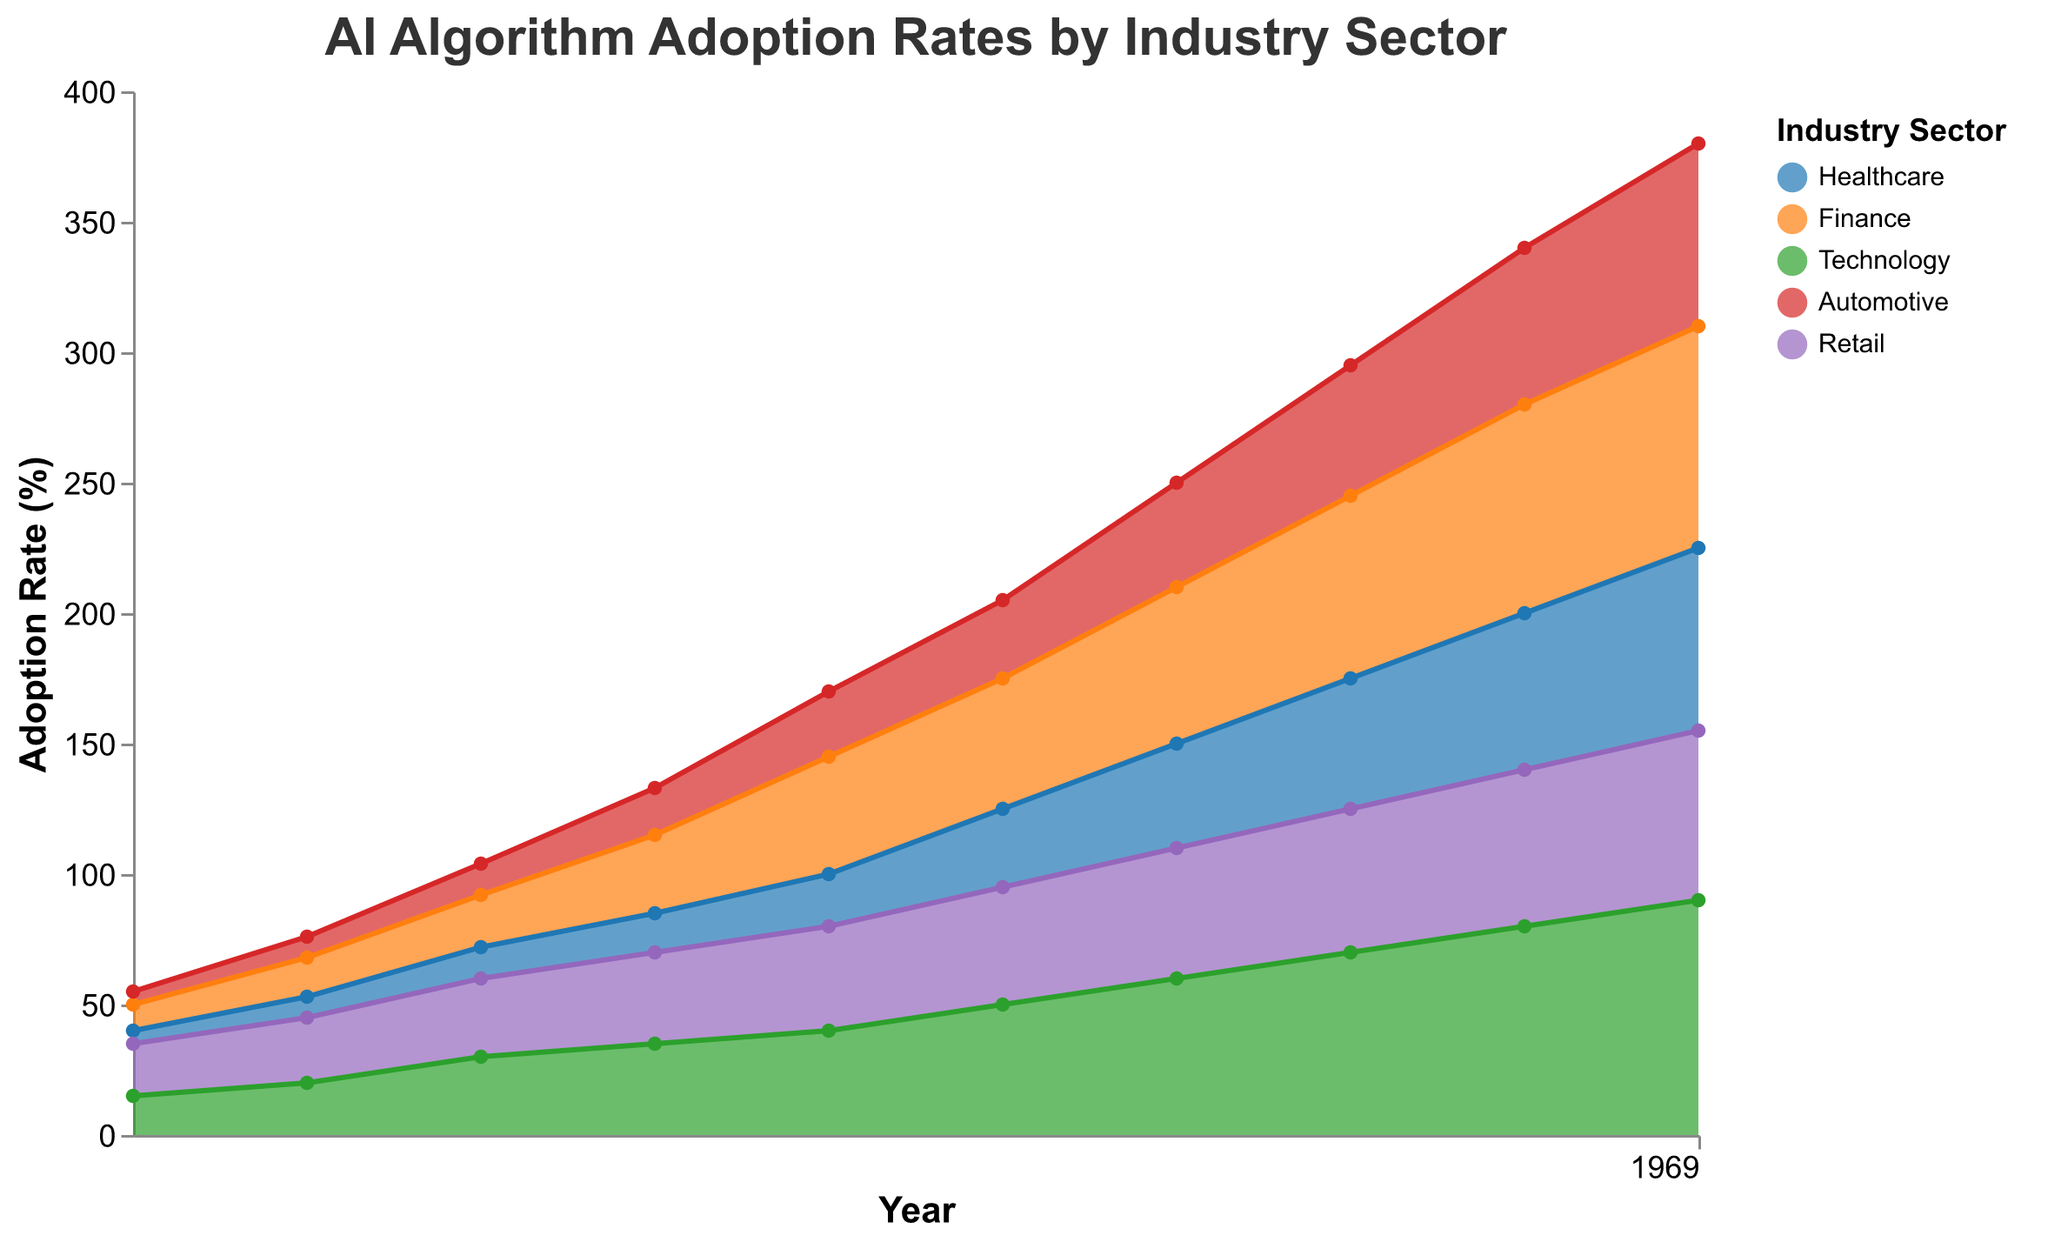What is the title of the figure? The title of the figure is visible at the top and reads "AI Algorithm Adoption Rates by Industry Sector".
Answer: AI Algorithm Adoption Rates by Industry Sector How many industry sectors are covered in the figure? Observe the color legend on the right side of the figure, which lists all industry sectors: "Healthcare", "Finance", "Technology", "Automotive", and "Retail".
Answer: 5 Which industry had the highest AI adoption rate in 2020? By looking at the 2020 vertical line, the highest point reached is in the "Technology" sector with an adoption rate of 70%.
Answer: Technology In which year did the AI adoption rate in the Healthcare sector first exceed 20%? Trace the Healthcare area until the adoption rate first surpasses the 20% mark, which happens in 2017.
Answer: 2017 How did the adoption rate in the Automotive sector change from 2013 to 2022? Check the beginning value for the Automotive sector in 2013 (5%) and the ending value in 2022 (70%). The adoption rate increased by 65%.
Answer: Increased by 65% What is the average AI adoption rate in the Finance sector over the decade? Sum the Finance adoption rates for each year (10, 15, 20, 30, 45, 50, 60, 70, 80, 85) and divide by the number of years (10). The average rate is 46.5%.
Answer: 46.5% Which industry showed the slowest growth in AI adoption between 2013 and 2022? Compare the total increase of adoption rates over the period for each industry. The Retail sector increased from 20% to 65%, a rise of 45%, which is the smallest among all sectors.
Answer: Retail How did the AI adoption trends in Retail and Technology compare over the last decade? Compare the trend lines for Retail and Technology. Retail increased from 20% to 65%, while Technology increased from 15% to 90%. Technology shows a steeper and larger increase.
Answer: Technology increased more Did the Healthcare sector ever surpass the Finance sector in AI adoption within the decade? Examine the relative positions of the Healthcare and Finance areas throughout the years. The Healthcare sector never surpassed the Finance sector in adoption rates.
Answer: No What was the combined adoption rate of Healthcare and Automotive sectors in 2016? Add the adoption rates for Healthcare (15%) and Automotive (18%) in 2016: 15% + 18% = 33%.
Answer: 33% 